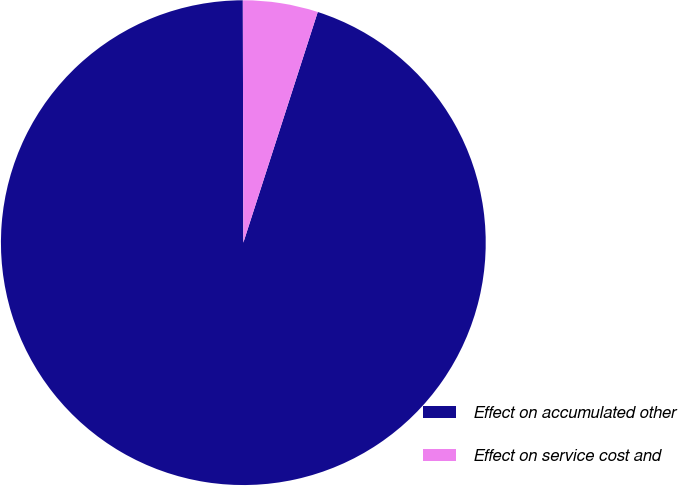Convert chart. <chart><loc_0><loc_0><loc_500><loc_500><pie_chart><fcel>Effect on accumulated other<fcel>Effect on service cost and<nl><fcel>95.0%<fcel>5.0%<nl></chart> 